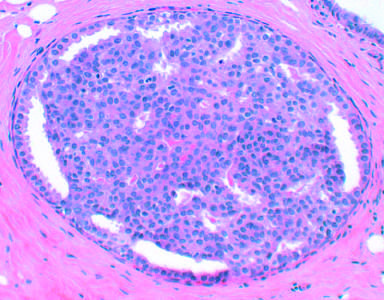what is proliferative breast disease characterized by?
Answer the question using a single word or phrase. An increased numbers of epithelial cells 